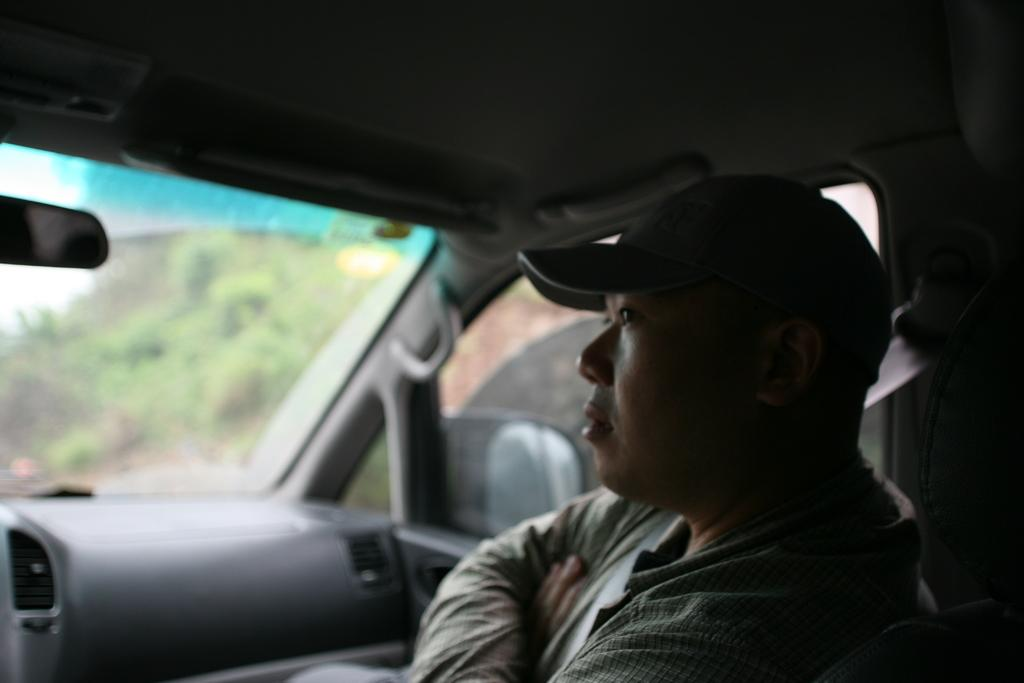What is the main subject of the image? There is a car in the image. Who is inside the car? There is a man inside the car. What is the man wearing? The man is wearing a check shirt and a cap. What is the man doing in the image? The man is staring at something. What can be seen in the background of the image? There is greenery in the background of the image. What type of list is the man holding in the image? There is no list present in the image; the man is not holding anything. 